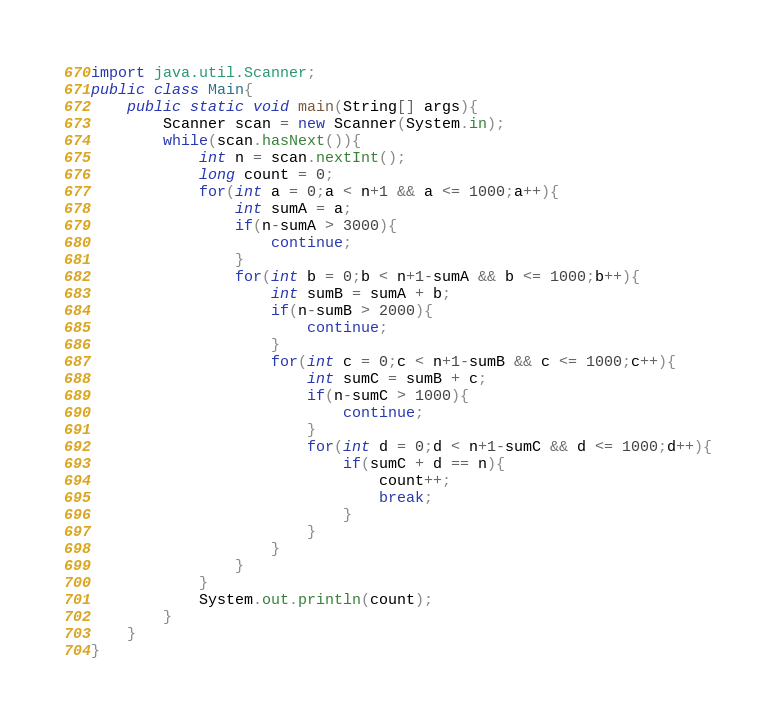<code> <loc_0><loc_0><loc_500><loc_500><_Java_>import java.util.Scanner;
public class Main{
	public static void main(String[] args){
		Scanner scan = new Scanner(System.in);
		while(scan.hasNext()){
			int n = scan.nextInt();
			long count = 0;
			for(int a = 0;a < n+1 && a <= 1000;a++){
				int sumA = a;
				if(n-sumA > 3000){
					continue;
				}
				for(int b = 0;b < n+1-sumA && b <= 1000;b++){
					int sumB = sumA + b;
					if(n-sumB > 2000){
						continue;
					}
					for(int c = 0;c < n+1-sumB && c <= 1000;c++){
						int sumC = sumB + c;
						if(n-sumC > 1000){
							continue;
						}
						for(int d = 0;d < n+1-sumC && d <= 1000;d++){
							if(sumC + d == n){
								count++;
								break;
							}
						}
					}
				}
			}
			System.out.println(count);
		}
	}
}</code> 